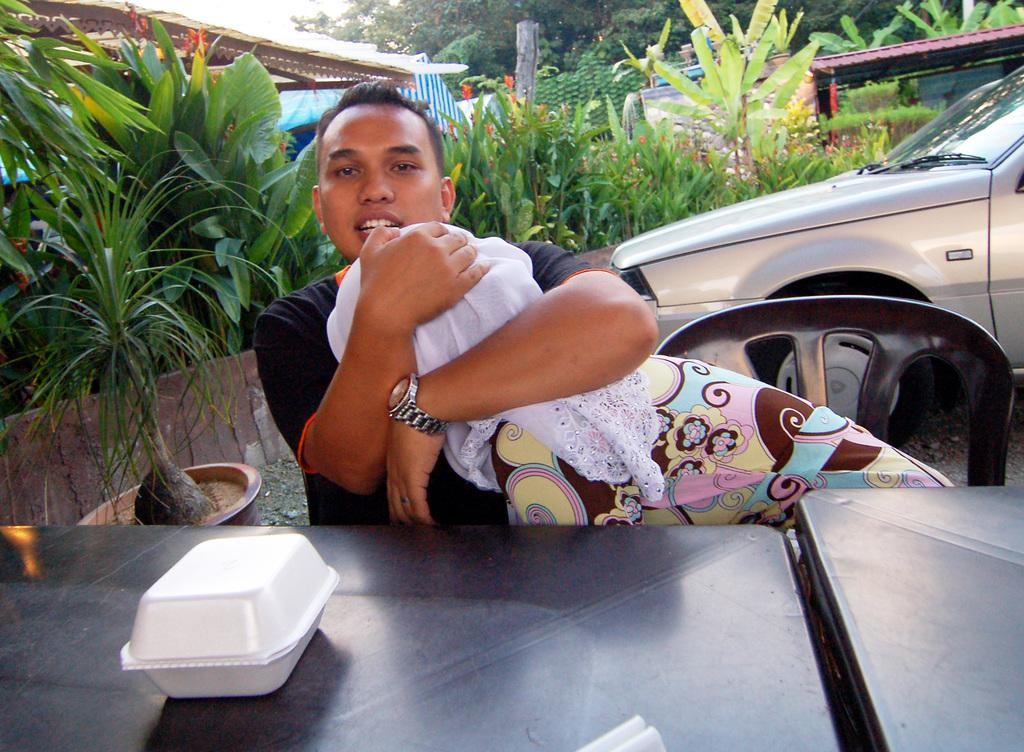What type of living organisms can be seen in the image? Plants can be seen in the image. What type of furniture is present in the image? There is a table and chairs in the image. What mode of transportation is visible in the image? There is a car in the image. What are the people in the image doing? People are sitting in the chairs. What is on the top of the image? Plants and trees are on the top of the image. Where is the car located in the image? The car is on the right side of the image. What object is on the table in the image? There is a box on the table. Can you tell me how many doors are visible in the image? There are no doors visible in the image. What type of boat is present in the image? There is no boat present in the image. 